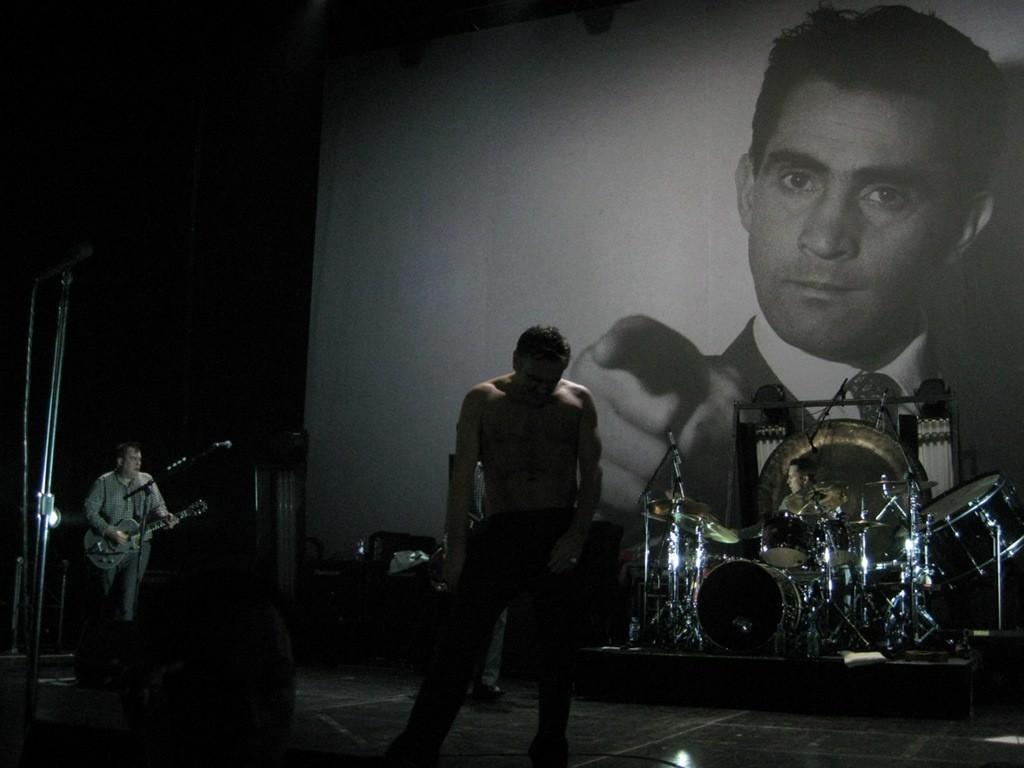How would you summarize this image in a sentence or two? In this picture we can see man standing beside to him we have drums and on this side person playing guitar in front of the mic and in background we can see banner of some person. 